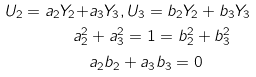Convert formula to latex. <formula><loc_0><loc_0><loc_500><loc_500>U _ { 2 } = a _ { 2 } Y _ { 2 } + & a _ { 3 } Y _ { 3 } , U _ { 3 } = b _ { 2 } Y _ { 2 } + b _ { 3 } Y _ { 3 } \\ a _ { 2 } ^ { 2 } & + a _ { 3 } ^ { 2 } = 1 = b _ { 2 } ^ { 2 } + b _ { 3 } ^ { 2 } \\ & a _ { 2 } b _ { 2 } + a _ { 3 } b _ { 3 } = 0</formula> 